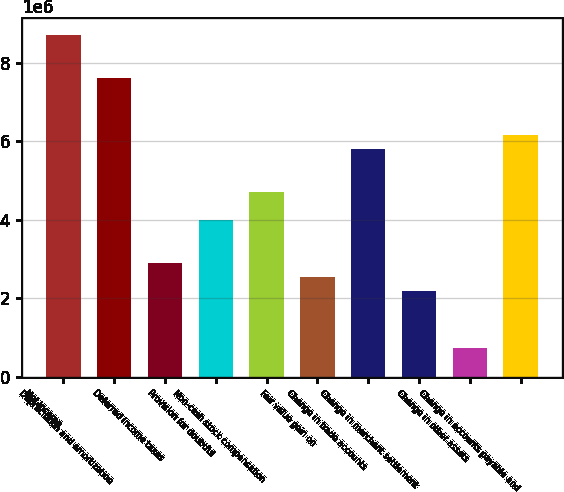Convert chart. <chart><loc_0><loc_0><loc_500><loc_500><bar_chart><fcel>Net income<fcel>Depreciation and amortization<fcel>Deferred income taxes<fcel>Provision for doubtful<fcel>Non-cash stock compensation<fcel>Fair value gain on<fcel>Change in trade accounts<fcel>Change in merchant settlement<fcel>Change in other assets<fcel>Change in accounts payable and<nl><fcel>8.71113e+06<fcel>7.62229e+06<fcel>2.90397e+06<fcel>3.99282e+06<fcel>4.71871e+06<fcel>2.54103e+06<fcel>5.80755e+06<fcel>2.17808e+06<fcel>726291<fcel>6.1705e+06<nl></chart> 